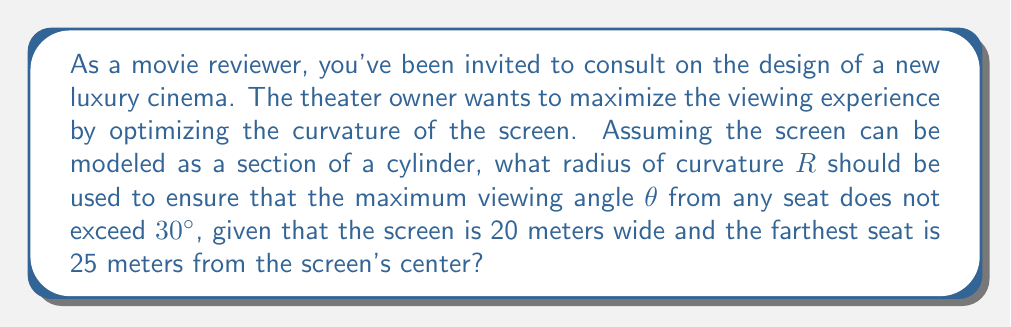What is the answer to this math problem? Let's approach this step-by-step:

1) First, we need to understand the geometry of the situation. The screen forms an arc of a circle when viewed from above, with the viewers positioned along a line perpendicular to the center of this arc.

2) Let's define our variables:
   $R$ = radius of curvature
   $w$ = width of the screen = 20 m
   $d$ = distance to the farthest seat = 25 m
   $\theta$ = maximum viewing angle = 30° = $\frac{\pi}{6}$ radians

3) The chord length of the arc (screen width) is related to the radius and the central angle $\alpha$ by:

   $$w = 2R \sin(\frac{\alpha}{2})$$

4) The viewing angle $\theta$ is related to the central angle $\alpha$ by:

   $$\theta = \frac{\alpha}{2}$$

5) Substituting $\theta = 30° = \frac{\pi}{6}$, we get $\alpha = \frac{\pi}{3}$

6) Now we can solve for $R$:

   $$20 = 2R \sin(\frac{\pi}{6})$$
   $$R = \frac{20}{2\sin(\frac{\pi}{6})} = \frac{20}{\sin(\frac{\pi}{3})} = \frac{20}{\frac{\sqrt{3}}{2}} = \frac{40}{\sqrt{3}} \approx 23.09 \text{ m}$$

7) However, we need to check if this radius satisfies the condition that the farthest seat (25 m away) doesn't exceed the 30° viewing angle.

8) The maximum viewing angle from the farthest seat is:

   $$\theta_{max} = \arctan(\frac{w/2}{d}) = \arctan(\frac{10}{25}) \approx 21.8°$$

9) Since 21.8° < 30°, our calculated radius satisfies all conditions.

[asy]
import geometry;

real R = 23.09;
real w = 20;
real d = 25;

pair O = (0,0);
pair A = (R,0);
pair B = (-R,0);
pair C = (0,-d);

draw(arc(O,R,180,360));
draw(A--B);
draw(C--O);

label("Screen", (0,R), N);
label("R", (R/2,R/2), NE);
label("w", (0,0), S);
label("d", (0,-d/2), E);
label("Farthest seat", C, S);

dot(O);
dot(C);
[/asy]
Answer: The optimal radius of curvature for the cinema screen is approximately $R = \frac{40}{\sqrt{3}} \approx 23.09$ meters. 